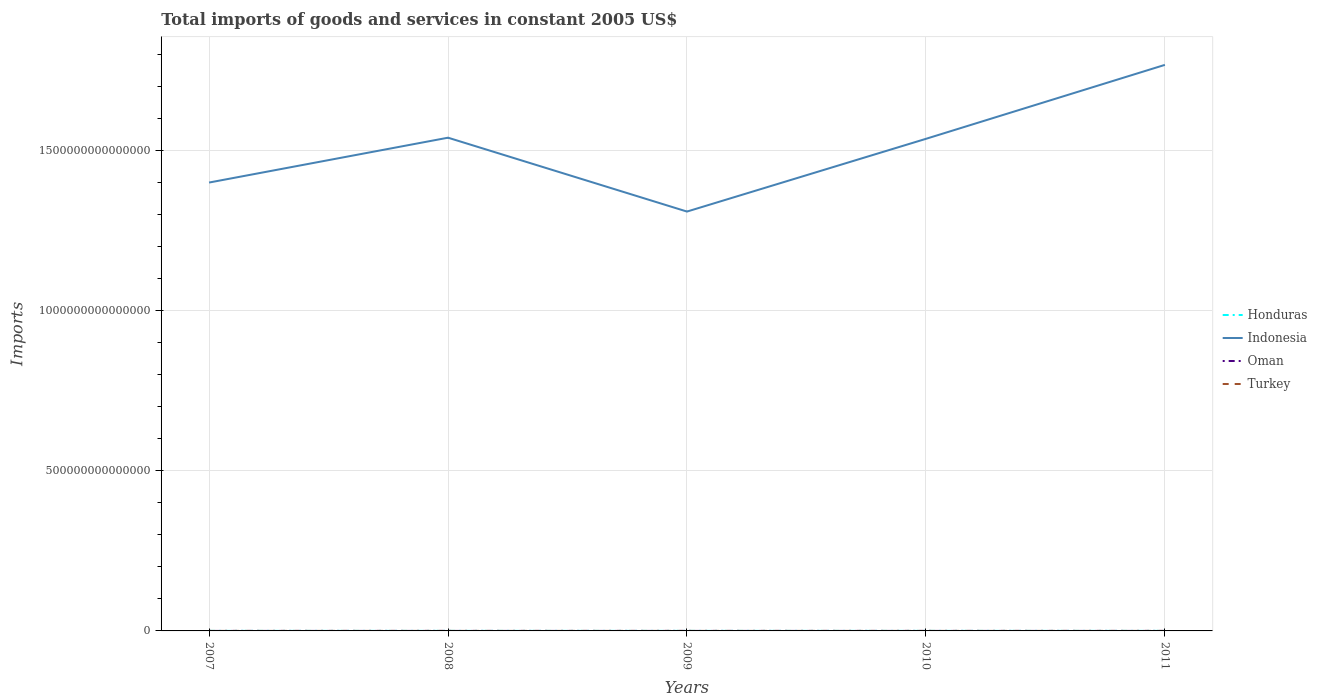How many different coloured lines are there?
Your answer should be compact. 4. Is the number of lines equal to the number of legend labels?
Provide a succinct answer. Yes. Across all years, what is the maximum total imports of goods and services in Oman?
Offer a very short reply. 6.02e+09. What is the total total imports of goods and services in Honduras in the graph?
Offer a very short reply. -1.34e+1. What is the difference between the highest and the second highest total imports of goods and services in Indonesia?
Provide a short and direct response. 4.58e+14. What is the difference between two consecutive major ticks on the Y-axis?
Your response must be concise. 5.00e+14. Are the values on the major ticks of Y-axis written in scientific E-notation?
Make the answer very short. No. Does the graph contain grids?
Your answer should be very brief. Yes. How many legend labels are there?
Ensure brevity in your answer.  4. How are the legend labels stacked?
Offer a very short reply. Vertical. What is the title of the graph?
Your answer should be compact. Total imports of goods and services in constant 2005 US$. Does "OECD members" appear as one of the legend labels in the graph?
Your answer should be compact. No. What is the label or title of the X-axis?
Your response must be concise. Years. What is the label or title of the Y-axis?
Provide a short and direct response. Imports. What is the Imports of Honduras in 2007?
Your answer should be very brief. 1.16e+11. What is the Imports in Indonesia in 2007?
Provide a succinct answer. 1.40e+15. What is the Imports in Oman in 2007?
Give a very brief answer. 6.45e+09. What is the Imports in Turkey in 2007?
Ensure brevity in your answer.  2.99e+1. What is the Imports of Honduras in 2008?
Keep it short and to the point. 1.19e+11. What is the Imports in Indonesia in 2008?
Offer a terse response. 1.54e+15. What is the Imports in Oman in 2008?
Your answer should be compact. 7.74e+09. What is the Imports of Turkey in 2008?
Make the answer very short. 2.87e+1. What is the Imports in Honduras in 2009?
Provide a short and direct response. 8.80e+1. What is the Imports in Indonesia in 2009?
Provide a succinct answer. 1.31e+15. What is the Imports in Oman in 2009?
Your answer should be very brief. 6.02e+09. What is the Imports in Turkey in 2009?
Offer a terse response. 2.46e+1. What is the Imports in Honduras in 2010?
Offer a very short reply. 1.01e+11. What is the Imports in Indonesia in 2010?
Your answer should be compact. 1.54e+15. What is the Imports of Oman in 2010?
Give a very brief answer. 7.37e+09. What is the Imports of Turkey in 2010?
Your response must be concise. 2.97e+1. What is the Imports of Honduras in 2011?
Your answer should be very brief. 1.14e+11. What is the Imports of Indonesia in 2011?
Ensure brevity in your answer.  1.77e+15. What is the Imports of Oman in 2011?
Your answer should be compact. 1.09e+1. What is the Imports of Turkey in 2011?
Provide a short and direct response. 3.28e+1. Across all years, what is the maximum Imports of Honduras?
Offer a terse response. 1.19e+11. Across all years, what is the maximum Imports in Indonesia?
Make the answer very short. 1.77e+15. Across all years, what is the maximum Imports in Oman?
Offer a very short reply. 1.09e+1. Across all years, what is the maximum Imports in Turkey?
Provide a succinct answer. 3.28e+1. Across all years, what is the minimum Imports in Honduras?
Your answer should be compact. 8.80e+1. Across all years, what is the minimum Imports in Indonesia?
Provide a short and direct response. 1.31e+15. Across all years, what is the minimum Imports of Oman?
Offer a very short reply. 6.02e+09. Across all years, what is the minimum Imports of Turkey?
Give a very brief answer. 2.46e+1. What is the total Imports of Honduras in the graph?
Your answer should be compact. 5.39e+11. What is the total Imports of Indonesia in the graph?
Offer a terse response. 7.56e+15. What is the total Imports of Oman in the graph?
Your answer should be very brief. 3.85e+1. What is the total Imports of Turkey in the graph?
Provide a succinct answer. 1.46e+11. What is the difference between the Imports of Honduras in 2007 and that in 2008?
Provide a succinct answer. -2.77e+09. What is the difference between the Imports of Indonesia in 2007 and that in 2008?
Your answer should be compact. -1.40e+14. What is the difference between the Imports in Oman in 2007 and that in 2008?
Ensure brevity in your answer.  -1.29e+09. What is the difference between the Imports in Turkey in 2007 and that in 2008?
Keep it short and to the point. 1.24e+09. What is the difference between the Imports of Honduras in 2007 and that in 2009?
Offer a very short reply. 2.85e+1. What is the difference between the Imports in Indonesia in 2007 and that in 2009?
Ensure brevity in your answer.  9.07e+13. What is the difference between the Imports of Oman in 2007 and that in 2009?
Keep it short and to the point. 4.37e+08. What is the difference between the Imports in Turkey in 2007 and that in 2009?
Your answer should be very brief. 5.34e+09. What is the difference between the Imports of Honduras in 2007 and that in 2010?
Give a very brief answer. 1.51e+1. What is the difference between the Imports of Indonesia in 2007 and that in 2010?
Offer a terse response. -1.37e+14. What is the difference between the Imports of Oman in 2007 and that in 2010?
Ensure brevity in your answer.  -9.18e+08. What is the difference between the Imports in Turkey in 2007 and that in 2010?
Provide a succinct answer. 2.47e+08. What is the difference between the Imports in Honduras in 2007 and that in 2011?
Give a very brief answer. 2.26e+09. What is the difference between the Imports of Indonesia in 2007 and that in 2011?
Ensure brevity in your answer.  -3.68e+14. What is the difference between the Imports in Oman in 2007 and that in 2011?
Offer a very short reply. -4.47e+09. What is the difference between the Imports of Turkey in 2007 and that in 2011?
Give a very brief answer. -2.92e+09. What is the difference between the Imports in Honduras in 2008 and that in 2009?
Your response must be concise. 3.12e+1. What is the difference between the Imports of Indonesia in 2008 and that in 2009?
Offer a terse response. 2.31e+14. What is the difference between the Imports of Oman in 2008 and that in 2009?
Keep it short and to the point. 1.73e+09. What is the difference between the Imports in Turkey in 2008 and that in 2009?
Provide a succinct answer. 4.10e+09. What is the difference between the Imports of Honduras in 2008 and that in 2010?
Offer a terse response. 1.79e+1. What is the difference between the Imports in Indonesia in 2008 and that in 2010?
Provide a succinct answer. 3.56e+12. What is the difference between the Imports in Oman in 2008 and that in 2010?
Give a very brief answer. 3.73e+08. What is the difference between the Imports of Turkey in 2008 and that in 2010?
Keep it short and to the point. -9.88e+08. What is the difference between the Imports of Honduras in 2008 and that in 2011?
Provide a succinct answer. 5.03e+09. What is the difference between the Imports in Indonesia in 2008 and that in 2011?
Make the answer very short. -2.28e+14. What is the difference between the Imports in Oman in 2008 and that in 2011?
Make the answer very short. -3.18e+09. What is the difference between the Imports in Turkey in 2008 and that in 2011?
Your answer should be compact. -4.16e+09. What is the difference between the Imports of Honduras in 2009 and that in 2010?
Provide a succinct answer. -1.34e+1. What is the difference between the Imports of Indonesia in 2009 and that in 2010?
Your answer should be compact. -2.27e+14. What is the difference between the Imports in Oman in 2009 and that in 2010?
Ensure brevity in your answer.  -1.35e+09. What is the difference between the Imports of Turkey in 2009 and that in 2010?
Provide a succinct answer. -5.09e+09. What is the difference between the Imports in Honduras in 2009 and that in 2011?
Provide a short and direct response. -2.62e+1. What is the difference between the Imports of Indonesia in 2009 and that in 2011?
Offer a terse response. -4.58e+14. What is the difference between the Imports in Oman in 2009 and that in 2011?
Your answer should be very brief. -4.91e+09. What is the difference between the Imports of Turkey in 2009 and that in 2011?
Give a very brief answer. -8.26e+09. What is the difference between the Imports of Honduras in 2010 and that in 2011?
Provide a short and direct response. -1.28e+1. What is the difference between the Imports in Indonesia in 2010 and that in 2011?
Provide a succinct answer. -2.31e+14. What is the difference between the Imports in Oman in 2010 and that in 2011?
Provide a short and direct response. -3.55e+09. What is the difference between the Imports of Turkey in 2010 and that in 2011?
Offer a very short reply. -3.17e+09. What is the difference between the Imports in Honduras in 2007 and the Imports in Indonesia in 2008?
Keep it short and to the point. -1.54e+15. What is the difference between the Imports in Honduras in 2007 and the Imports in Oman in 2008?
Your answer should be compact. 1.09e+11. What is the difference between the Imports of Honduras in 2007 and the Imports of Turkey in 2008?
Your answer should be very brief. 8.78e+1. What is the difference between the Imports of Indonesia in 2007 and the Imports of Oman in 2008?
Offer a very short reply. 1.40e+15. What is the difference between the Imports of Indonesia in 2007 and the Imports of Turkey in 2008?
Make the answer very short. 1.40e+15. What is the difference between the Imports in Oman in 2007 and the Imports in Turkey in 2008?
Offer a terse response. -2.22e+1. What is the difference between the Imports of Honduras in 2007 and the Imports of Indonesia in 2009?
Offer a terse response. -1.31e+15. What is the difference between the Imports of Honduras in 2007 and the Imports of Oman in 2009?
Ensure brevity in your answer.  1.10e+11. What is the difference between the Imports in Honduras in 2007 and the Imports in Turkey in 2009?
Offer a very short reply. 9.19e+1. What is the difference between the Imports in Indonesia in 2007 and the Imports in Oman in 2009?
Your answer should be compact. 1.40e+15. What is the difference between the Imports in Indonesia in 2007 and the Imports in Turkey in 2009?
Keep it short and to the point. 1.40e+15. What is the difference between the Imports of Oman in 2007 and the Imports of Turkey in 2009?
Provide a short and direct response. -1.81e+1. What is the difference between the Imports in Honduras in 2007 and the Imports in Indonesia in 2010?
Make the answer very short. -1.54e+15. What is the difference between the Imports in Honduras in 2007 and the Imports in Oman in 2010?
Your response must be concise. 1.09e+11. What is the difference between the Imports of Honduras in 2007 and the Imports of Turkey in 2010?
Keep it short and to the point. 8.68e+1. What is the difference between the Imports of Indonesia in 2007 and the Imports of Oman in 2010?
Your answer should be very brief. 1.40e+15. What is the difference between the Imports of Indonesia in 2007 and the Imports of Turkey in 2010?
Provide a succinct answer. 1.40e+15. What is the difference between the Imports of Oman in 2007 and the Imports of Turkey in 2010?
Your response must be concise. -2.32e+1. What is the difference between the Imports of Honduras in 2007 and the Imports of Indonesia in 2011?
Offer a terse response. -1.77e+15. What is the difference between the Imports of Honduras in 2007 and the Imports of Oman in 2011?
Your response must be concise. 1.06e+11. What is the difference between the Imports in Honduras in 2007 and the Imports in Turkey in 2011?
Provide a short and direct response. 8.36e+1. What is the difference between the Imports of Indonesia in 2007 and the Imports of Oman in 2011?
Give a very brief answer. 1.40e+15. What is the difference between the Imports of Indonesia in 2007 and the Imports of Turkey in 2011?
Provide a succinct answer. 1.40e+15. What is the difference between the Imports of Oman in 2007 and the Imports of Turkey in 2011?
Give a very brief answer. -2.64e+1. What is the difference between the Imports in Honduras in 2008 and the Imports in Indonesia in 2009?
Offer a terse response. -1.31e+15. What is the difference between the Imports in Honduras in 2008 and the Imports in Oman in 2009?
Ensure brevity in your answer.  1.13e+11. What is the difference between the Imports in Honduras in 2008 and the Imports in Turkey in 2009?
Keep it short and to the point. 9.46e+1. What is the difference between the Imports of Indonesia in 2008 and the Imports of Oman in 2009?
Provide a succinct answer. 1.54e+15. What is the difference between the Imports in Indonesia in 2008 and the Imports in Turkey in 2009?
Your response must be concise. 1.54e+15. What is the difference between the Imports of Oman in 2008 and the Imports of Turkey in 2009?
Offer a very short reply. -1.68e+1. What is the difference between the Imports of Honduras in 2008 and the Imports of Indonesia in 2010?
Your response must be concise. -1.54e+15. What is the difference between the Imports of Honduras in 2008 and the Imports of Oman in 2010?
Your answer should be very brief. 1.12e+11. What is the difference between the Imports in Honduras in 2008 and the Imports in Turkey in 2010?
Make the answer very short. 8.95e+1. What is the difference between the Imports of Indonesia in 2008 and the Imports of Oman in 2010?
Your answer should be compact. 1.54e+15. What is the difference between the Imports in Indonesia in 2008 and the Imports in Turkey in 2010?
Make the answer very short. 1.54e+15. What is the difference between the Imports of Oman in 2008 and the Imports of Turkey in 2010?
Your response must be concise. -2.19e+1. What is the difference between the Imports of Honduras in 2008 and the Imports of Indonesia in 2011?
Your answer should be compact. -1.77e+15. What is the difference between the Imports of Honduras in 2008 and the Imports of Oman in 2011?
Give a very brief answer. 1.08e+11. What is the difference between the Imports of Honduras in 2008 and the Imports of Turkey in 2011?
Offer a very short reply. 8.64e+1. What is the difference between the Imports of Indonesia in 2008 and the Imports of Oman in 2011?
Offer a very short reply. 1.54e+15. What is the difference between the Imports of Indonesia in 2008 and the Imports of Turkey in 2011?
Your answer should be compact. 1.54e+15. What is the difference between the Imports of Oman in 2008 and the Imports of Turkey in 2011?
Provide a succinct answer. -2.51e+1. What is the difference between the Imports of Honduras in 2009 and the Imports of Indonesia in 2010?
Your answer should be compact. -1.54e+15. What is the difference between the Imports in Honduras in 2009 and the Imports in Oman in 2010?
Your response must be concise. 8.06e+1. What is the difference between the Imports of Honduras in 2009 and the Imports of Turkey in 2010?
Give a very brief answer. 5.83e+1. What is the difference between the Imports of Indonesia in 2009 and the Imports of Oman in 2010?
Provide a succinct answer. 1.31e+15. What is the difference between the Imports of Indonesia in 2009 and the Imports of Turkey in 2010?
Your answer should be very brief. 1.31e+15. What is the difference between the Imports in Oman in 2009 and the Imports in Turkey in 2010?
Offer a terse response. -2.37e+1. What is the difference between the Imports of Honduras in 2009 and the Imports of Indonesia in 2011?
Ensure brevity in your answer.  -1.77e+15. What is the difference between the Imports of Honduras in 2009 and the Imports of Oman in 2011?
Provide a succinct answer. 7.70e+1. What is the difference between the Imports of Honduras in 2009 and the Imports of Turkey in 2011?
Offer a very short reply. 5.51e+1. What is the difference between the Imports of Indonesia in 2009 and the Imports of Oman in 2011?
Offer a terse response. 1.31e+15. What is the difference between the Imports of Indonesia in 2009 and the Imports of Turkey in 2011?
Offer a very short reply. 1.31e+15. What is the difference between the Imports in Oman in 2009 and the Imports in Turkey in 2011?
Your answer should be compact. -2.68e+1. What is the difference between the Imports in Honduras in 2010 and the Imports in Indonesia in 2011?
Provide a succinct answer. -1.77e+15. What is the difference between the Imports of Honduras in 2010 and the Imports of Oman in 2011?
Offer a very short reply. 9.04e+1. What is the difference between the Imports of Honduras in 2010 and the Imports of Turkey in 2011?
Your answer should be compact. 6.85e+1. What is the difference between the Imports of Indonesia in 2010 and the Imports of Oman in 2011?
Ensure brevity in your answer.  1.54e+15. What is the difference between the Imports of Indonesia in 2010 and the Imports of Turkey in 2011?
Offer a very short reply. 1.54e+15. What is the difference between the Imports in Oman in 2010 and the Imports in Turkey in 2011?
Offer a very short reply. -2.55e+1. What is the average Imports in Honduras per year?
Give a very brief answer. 1.08e+11. What is the average Imports in Indonesia per year?
Offer a very short reply. 1.51e+15. What is the average Imports in Oman per year?
Your answer should be very brief. 7.70e+09. What is the average Imports in Turkey per year?
Provide a short and direct response. 2.91e+1. In the year 2007, what is the difference between the Imports in Honduras and Imports in Indonesia?
Offer a very short reply. -1.40e+15. In the year 2007, what is the difference between the Imports of Honduras and Imports of Oman?
Offer a terse response. 1.10e+11. In the year 2007, what is the difference between the Imports of Honduras and Imports of Turkey?
Your answer should be compact. 8.65e+1. In the year 2007, what is the difference between the Imports in Indonesia and Imports in Oman?
Offer a very short reply. 1.40e+15. In the year 2007, what is the difference between the Imports in Indonesia and Imports in Turkey?
Your response must be concise. 1.40e+15. In the year 2007, what is the difference between the Imports in Oman and Imports in Turkey?
Keep it short and to the point. -2.35e+1. In the year 2008, what is the difference between the Imports of Honduras and Imports of Indonesia?
Give a very brief answer. -1.54e+15. In the year 2008, what is the difference between the Imports of Honduras and Imports of Oman?
Your answer should be compact. 1.11e+11. In the year 2008, what is the difference between the Imports of Honduras and Imports of Turkey?
Offer a very short reply. 9.05e+1. In the year 2008, what is the difference between the Imports in Indonesia and Imports in Oman?
Give a very brief answer. 1.54e+15. In the year 2008, what is the difference between the Imports of Indonesia and Imports of Turkey?
Your answer should be very brief. 1.54e+15. In the year 2008, what is the difference between the Imports of Oman and Imports of Turkey?
Give a very brief answer. -2.09e+1. In the year 2009, what is the difference between the Imports of Honduras and Imports of Indonesia?
Your answer should be compact. -1.31e+15. In the year 2009, what is the difference between the Imports of Honduras and Imports of Oman?
Make the answer very short. 8.19e+1. In the year 2009, what is the difference between the Imports of Honduras and Imports of Turkey?
Your answer should be compact. 6.34e+1. In the year 2009, what is the difference between the Imports in Indonesia and Imports in Oman?
Make the answer very short. 1.31e+15. In the year 2009, what is the difference between the Imports of Indonesia and Imports of Turkey?
Your response must be concise. 1.31e+15. In the year 2009, what is the difference between the Imports in Oman and Imports in Turkey?
Ensure brevity in your answer.  -1.86e+1. In the year 2010, what is the difference between the Imports in Honduras and Imports in Indonesia?
Provide a succinct answer. -1.54e+15. In the year 2010, what is the difference between the Imports of Honduras and Imports of Oman?
Give a very brief answer. 9.40e+1. In the year 2010, what is the difference between the Imports in Honduras and Imports in Turkey?
Provide a short and direct response. 7.17e+1. In the year 2010, what is the difference between the Imports of Indonesia and Imports of Oman?
Keep it short and to the point. 1.54e+15. In the year 2010, what is the difference between the Imports in Indonesia and Imports in Turkey?
Keep it short and to the point. 1.54e+15. In the year 2010, what is the difference between the Imports in Oman and Imports in Turkey?
Your answer should be very brief. -2.23e+1. In the year 2011, what is the difference between the Imports in Honduras and Imports in Indonesia?
Your response must be concise. -1.77e+15. In the year 2011, what is the difference between the Imports of Honduras and Imports of Oman?
Your response must be concise. 1.03e+11. In the year 2011, what is the difference between the Imports in Honduras and Imports in Turkey?
Provide a short and direct response. 8.13e+1. In the year 2011, what is the difference between the Imports in Indonesia and Imports in Oman?
Provide a succinct answer. 1.77e+15. In the year 2011, what is the difference between the Imports in Indonesia and Imports in Turkey?
Keep it short and to the point. 1.77e+15. In the year 2011, what is the difference between the Imports in Oman and Imports in Turkey?
Your response must be concise. -2.19e+1. What is the ratio of the Imports of Honduras in 2007 to that in 2008?
Ensure brevity in your answer.  0.98. What is the ratio of the Imports of Oman in 2007 to that in 2008?
Your answer should be very brief. 0.83. What is the ratio of the Imports in Turkey in 2007 to that in 2008?
Your answer should be compact. 1.04. What is the ratio of the Imports in Honduras in 2007 to that in 2009?
Keep it short and to the point. 1.32. What is the ratio of the Imports in Indonesia in 2007 to that in 2009?
Your answer should be very brief. 1.07. What is the ratio of the Imports in Oman in 2007 to that in 2009?
Provide a short and direct response. 1.07. What is the ratio of the Imports of Turkey in 2007 to that in 2009?
Offer a terse response. 1.22. What is the ratio of the Imports of Honduras in 2007 to that in 2010?
Your response must be concise. 1.15. What is the ratio of the Imports of Indonesia in 2007 to that in 2010?
Your answer should be very brief. 0.91. What is the ratio of the Imports in Oman in 2007 to that in 2010?
Offer a terse response. 0.88. What is the ratio of the Imports in Turkey in 2007 to that in 2010?
Provide a succinct answer. 1.01. What is the ratio of the Imports of Honduras in 2007 to that in 2011?
Give a very brief answer. 1.02. What is the ratio of the Imports of Indonesia in 2007 to that in 2011?
Make the answer very short. 0.79. What is the ratio of the Imports in Oman in 2007 to that in 2011?
Keep it short and to the point. 0.59. What is the ratio of the Imports in Turkey in 2007 to that in 2011?
Provide a succinct answer. 0.91. What is the ratio of the Imports in Honduras in 2008 to that in 2009?
Give a very brief answer. 1.36. What is the ratio of the Imports in Indonesia in 2008 to that in 2009?
Give a very brief answer. 1.18. What is the ratio of the Imports in Oman in 2008 to that in 2009?
Give a very brief answer. 1.29. What is the ratio of the Imports in Turkey in 2008 to that in 2009?
Make the answer very short. 1.17. What is the ratio of the Imports of Honduras in 2008 to that in 2010?
Offer a terse response. 1.18. What is the ratio of the Imports of Indonesia in 2008 to that in 2010?
Give a very brief answer. 1. What is the ratio of the Imports of Oman in 2008 to that in 2010?
Keep it short and to the point. 1.05. What is the ratio of the Imports of Turkey in 2008 to that in 2010?
Offer a very short reply. 0.97. What is the ratio of the Imports of Honduras in 2008 to that in 2011?
Make the answer very short. 1.04. What is the ratio of the Imports of Indonesia in 2008 to that in 2011?
Ensure brevity in your answer.  0.87. What is the ratio of the Imports in Oman in 2008 to that in 2011?
Your answer should be very brief. 0.71. What is the ratio of the Imports in Turkey in 2008 to that in 2011?
Provide a short and direct response. 0.87. What is the ratio of the Imports in Honduras in 2009 to that in 2010?
Give a very brief answer. 0.87. What is the ratio of the Imports of Indonesia in 2009 to that in 2010?
Offer a terse response. 0.85. What is the ratio of the Imports in Oman in 2009 to that in 2010?
Offer a very short reply. 0.82. What is the ratio of the Imports of Turkey in 2009 to that in 2010?
Offer a terse response. 0.83. What is the ratio of the Imports in Honduras in 2009 to that in 2011?
Make the answer very short. 0.77. What is the ratio of the Imports of Indonesia in 2009 to that in 2011?
Your answer should be very brief. 0.74. What is the ratio of the Imports in Oman in 2009 to that in 2011?
Give a very brief answer. 0.55. What is the ratio of the Imports in Turkey in 2009 to that in 2011?
Provide a succinct answer. 0.75. What is the ratio of the Imports in Honduras in 2010 to that in 2011?
Keep it short and to the point. 0.89. What is the ratio of the Imports in Indonesia in 2010 to that in 2011?
Ensure brevity in your answer.  0.87. What is the ratio of the Imports in Oman in 2010 to that in 2011?
Make the answer very short. 0.67. What is the ratio of the Imports in Turkey in 2010 to that in 2011?
Offer a very short reply. 0.9. What is the difference between the highest and the second highest Imports of Honduras?
Offer a very short reply. 2.77e+09. What is the difference between the highest and the second highest Imports in Indonesia?
Give a very brief answer. 2.28e+14. What is the difference between the highest and the second highest Imports of Oman?
Provide a short and direct response. 3.18e+09. What is the difference between the highest and the second highest Imports of Turkey?
Ensure brevity in your answer.  2.92e+09. What is the difference between the highest and the lowest Imports of Honduras?
Your answer should be compact. 3.12e+1. What is the difference between the highest and the lowest Imports in Indonesia?
Offer a terse response. 4.58e+14. What is the difference between the highest and the lowest Imports in Oman?
Provide a succinct answer. 4.91e+09. What is the difference between the highest and the lowest Imports in Turkey?
Give a very brief answer. 8.26e+09. 